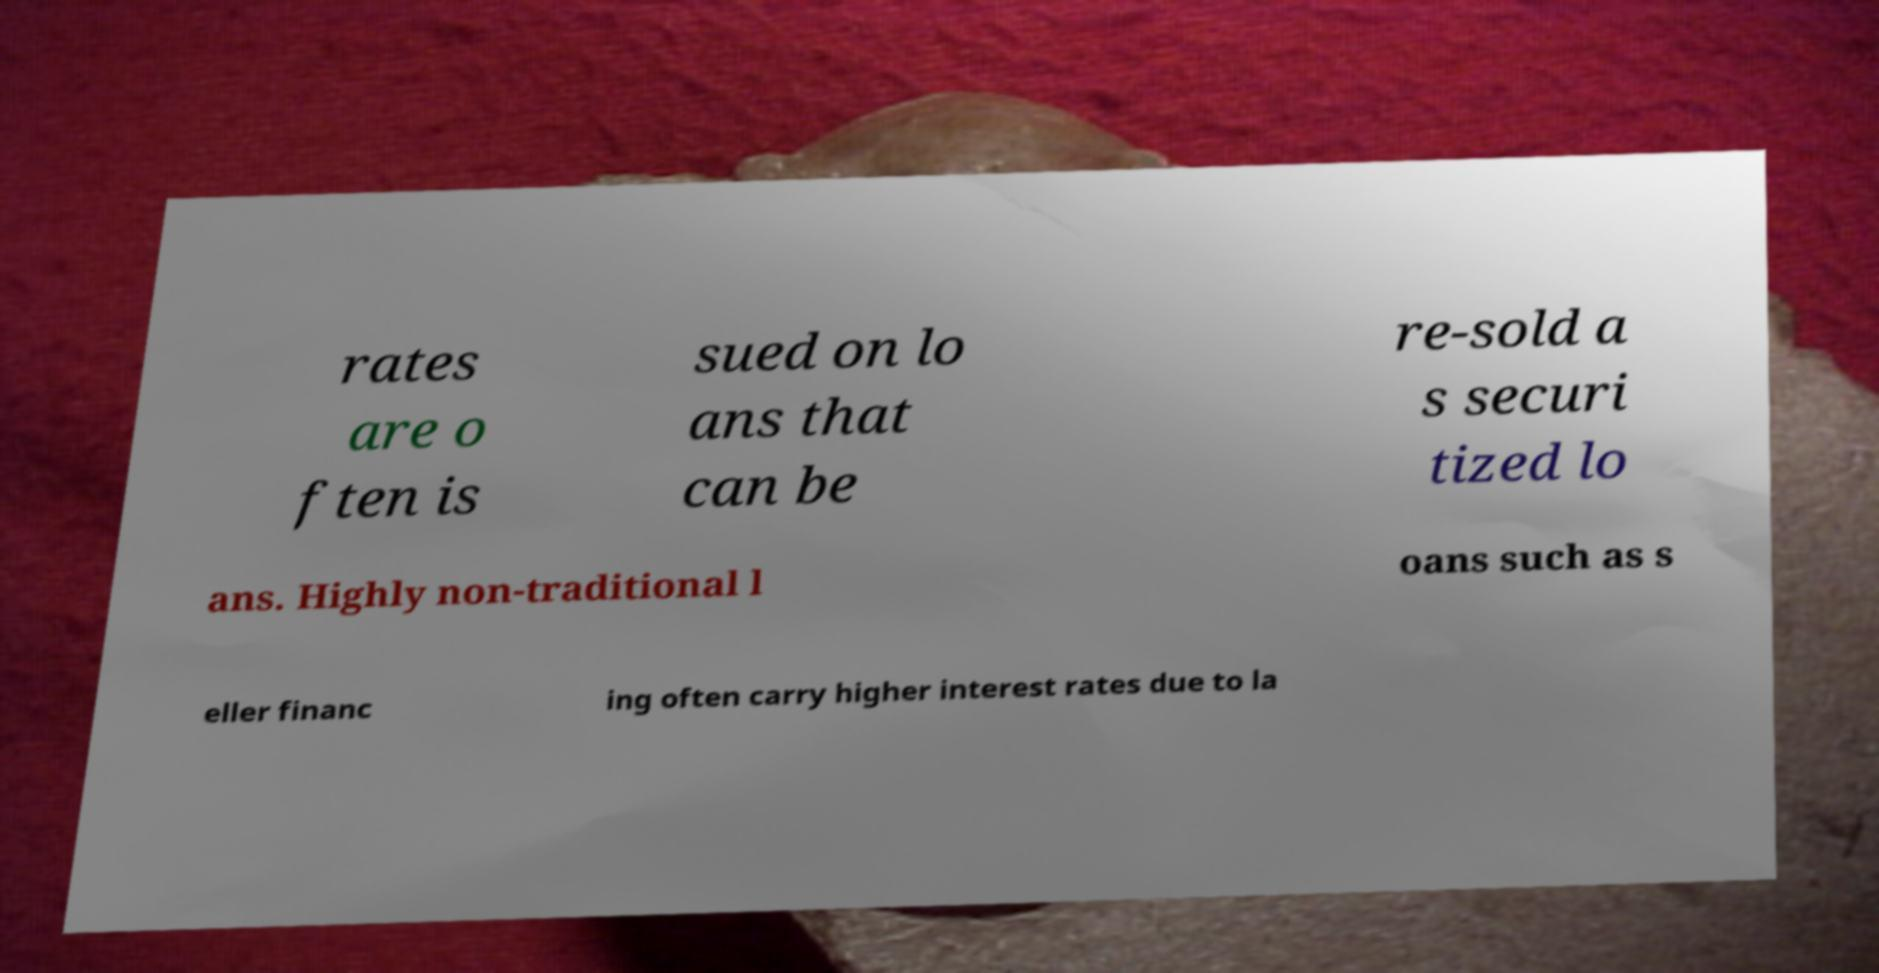Can you accurately transcribe the text from the provided image for me? rates are o ften is sued on lo ans that can be re-sold a s securi tized lo ans. Highly non-traditional l oans such as s eller financ ing often carry higher interest rates due to la 